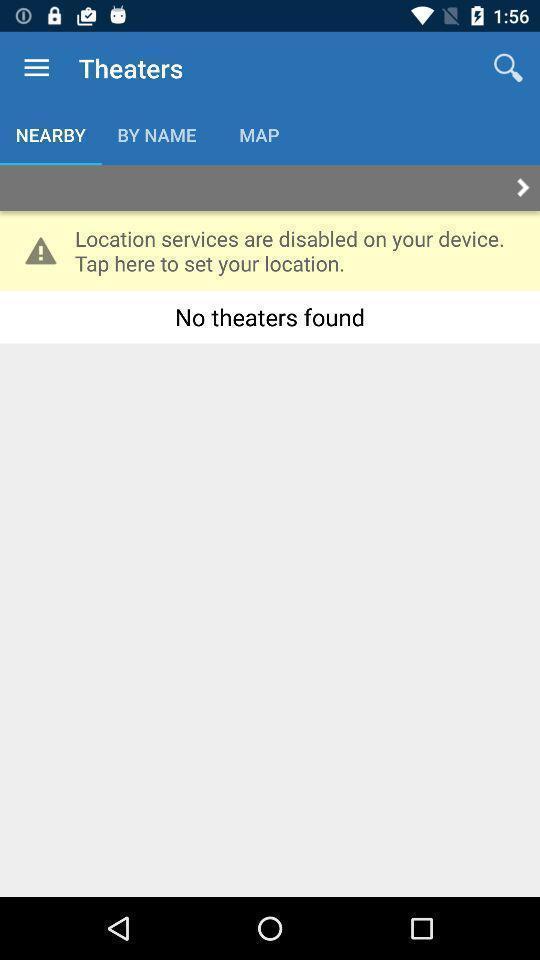Provide a textual representation of this image. Search page for finding nearby theaters. 